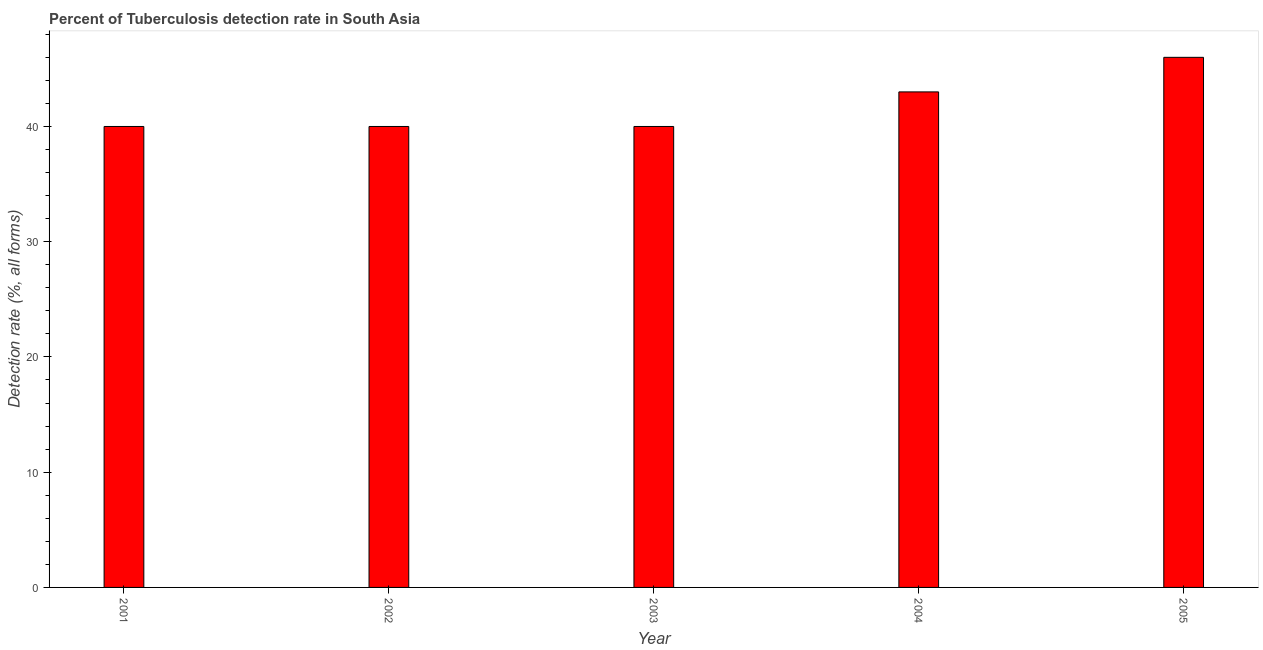Does the graph contain grids?
Keep it short and to the point. No. What is the title of the graph?
Your answer should be compact. Percent of Tuberculosis detection rate in South Asia. What is the label or title of the X-axis?
Provide a short and direct response. Year. What is the label or title of the Y-axis?
Offer a very short reply. Detection rate (%, all forms). What is the detection rate of tuberculosis in 2003?
Keep it short and to the point. 40. Across all years, what is the minimum detection rate of tuberculosis?
Give a very brief answer. 40. In which year was the detection rate of tuberculosis maximum?
Make the answer very short. 2005. What is the sum of the detection rate of tuberculosis?
Your answer should be very brief. 209. What is the average detection rate of tuberculosis per year?
Keep it short and to the point. 41. What is the ratio of the detection rate of tuberculosis in 2002 to that in 2005?
Ensure brevity in your answer.  0.87. In how many years, is the detection rate of tuberculosis greater than the average detection rate of tuberculosis taken over all years?
Make the answer very short. 2. What is the difference between two consecutive major ticks on the Y-axis?
Give a very brief answer. 10. Are the values on the major ticks of Y-axis written in scientific E-notation?
Provide a succinct answer. No. What is the Detection rate (%, all forms) of 2005?
Offer a terse response. 46. What is the difference between the Detection rate (%, all forms) in 2001 and 2002?
Keep it short and to the point. 0. What is the difference between the Detection rate (%, all forms) in 2001 and 2004?
Provide a short and direct response. -3. What is the difference between the Detection rate (%, all forms) in 2001 and 2005?
Your answer should be compact. -6. What is the difference between the Detection rate (%, all forms) in 2002 and 2004?
Provide a short and direct response. -3. What is the difference between the Detection rate (%, all forms) in 2003 and 2004?
Your answer should be compact. -3. What is the difference between the Detection rate (%, all forms) in 2003 and 2005?
Offer a terse response. -6. What is the ratio of the Detection rate (%, all forms) in 2001 to that in 2003?
Keep it short and to the point. 1. What is the ratio of the Detection rate (%, all forms) in 2001 to that in 2004?
Make the answer very short. 0.93. What is the ratio of the Detection rate (%, all forms) in 2001 to that in 2005?
Provide a short and direct response. 0.87. What is the ratio of the Detection rate (%, all forms) in 2002 to that in 2005?
Your answer should be compact. 0.87. What is the ratio of the Detection rate (%, all forms) in 2003 to that in 2004?
Keep it short and to the point. 0.93. What is the ratio of the Detection rate (%, all forms) in 2003 to that in 2005?
Keep it short and to the point. 0.87. What is the ratio of the Detection rate (%, all forms) in 2004 to that in 2005?
Provide a short and direct response. 0.94. 